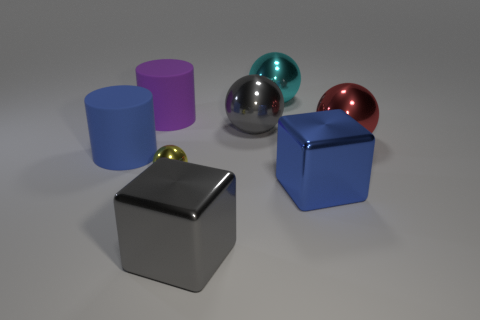Does the red object have the same size as the yellow object?
Give a very brief answer. No. There is a red thing; is its size the same as the metal sphere to the left of the gray metallic sphere?
Provide a short and direct response. No. Do the blue thing in front of the big blue matte cylinder and the sphere that is in front of the large blue rubber thing have the same size?
Your answer should be very brief. No. What size is the cylinder on the right side of the blue thing that is to the left of the tiny ball?
Keep it short and to the point. Large. There is a blue thing on the right side of the cyan sphere; what is its shape?
Keep it short and to the point. Cube. What is the blue thing that is right of the purple object on the left side of the gray metallic object that is behind the tiny ball made of?
Offer a very short reply. Metal. How many other objects are there of the same size as the blue cylinder?
Provide a succinct answer. 6. What is the material of the blue thing that is the same shape as the big purple object?
Your response must be concise. Rubber. The tiny metal object is what color?
Offer a terse response. Yellow. What is the color of the big shiny thing that is behind the cylinder that is behind the large red sphere?
Your response must be concise. Cyan. 